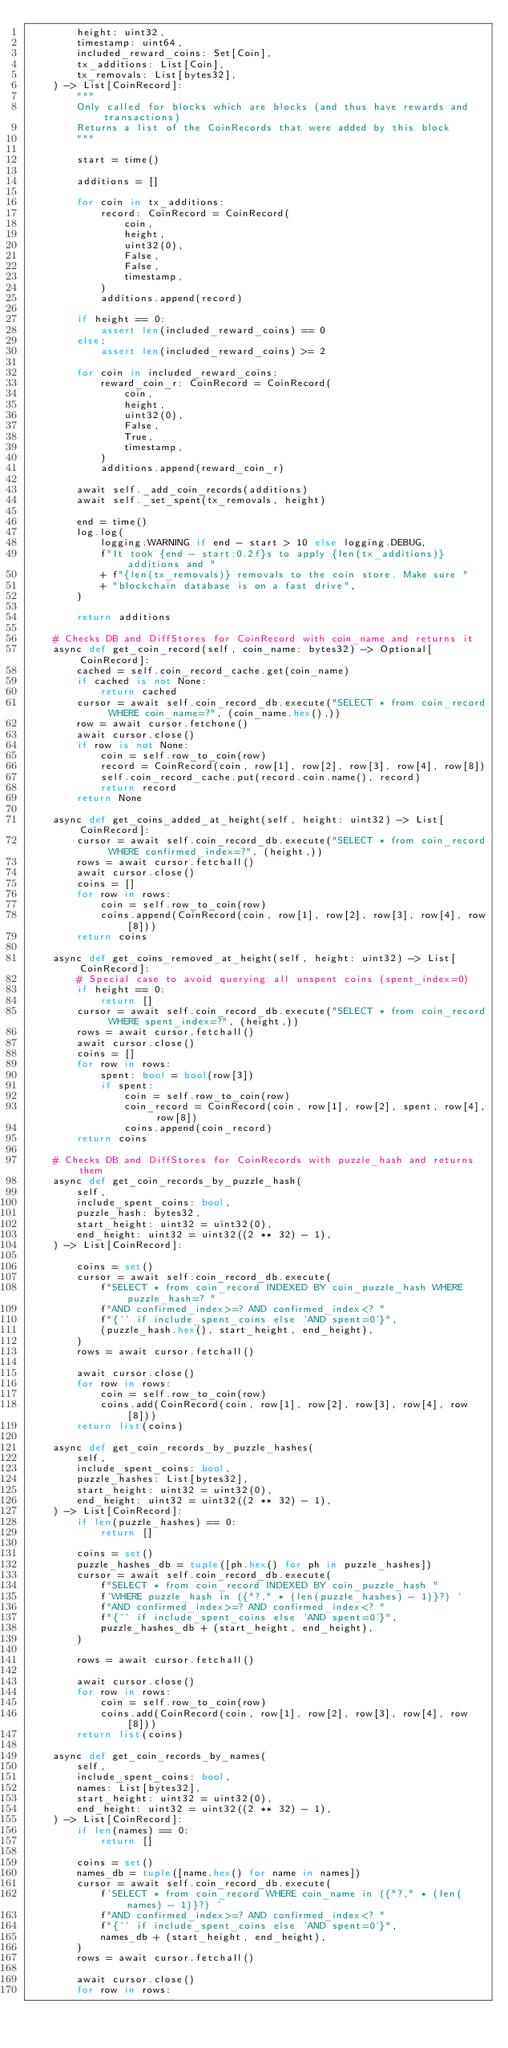<code> <loc_0><loc_0><loc_500><loc_500><_Python_>        height: uint32,
        timestamp: uint64,
        included_reward_coins: Set[Coin],
        tx_additions: List[Coin],
        tx_removals: List[bytes32],
    ) -> List[CoinRecord]:
        """
        Only called for blocks which are blocks (and thus have rewards and transactions)
        Returns a list of the CoinRecords that were added by this block
        """

        start = time()

        additions = []

        for coin in tx_additions:
            record: CoinRecord = CoinRecord(
                coin,
                height,
                uint32(0),
                False,
                False,
                timestamp,
            )
            additions.append(record)

        if height == 0:
            assert len(included_reward_coins) == 0
        else:
            assert len(included_reward_coins) >= 2

        for coin in included_reward_coins:
            reward_coin_r: CoinRecord = CoinRecord(
                coin,
                height,
                uint32(0),
                False,
                True,
                timestamp,
            )
            additions.append(reward_coin_r)

        await self._add_coin_records(additions)
        await self._set_spent(tx_removals, height)

        end = time()
        log.log(
            logging.WARNING if end - start > 10 else logging.DEBUG,
            f"It took {end - start:0.2f}s to apply {len(tx_additions)} additions and "
            + f"{len(tx_removals)} removals to the coin store. Make sure "
            + "blockchain database is on a fast drive",
        )

        return additions

    # Checks DB and DiffStores for CoinRecord with coin_name and returns it
    async def get_coin_record(self, coin_name: bytes32) -> Optional[CoinRecord]:
        cached = self.coin_record_cache.get(coin_name)
        if cached is not None:
            return cached
        cursor = await self.coin_record_db.execute("SELECT * from coin_record WHERE coin_name=?", (coin_name.hex(),))
        row = await cursor.fetchone()
        await cursor.close()
        if row is not None:
            coin = self.row_to_coin(row)
            record = CoinRecord(coin, row[1], row[2], row[3], row[4], row[8])
            self.coin_record_cache.put(record.coin.name(), record)
            return record
        return None

    async def get_coins_added_at_height(self, height: uint32) -> List[CoinRecord]:
        cursor = await self.coin_record_db.execute("SELECT * from coin_record WHERE confirmed_index=?", (height,))
        rows = await cursor.fetchall()
        await cursor.close()
        coins = []
        for row in rows:
            coin = self.row_to_coin(row)
            coins.append(CoinRecord(coin, row[1], row[2], row[3], row[4], row[8]))
        return coins

    async def get_coins_removed_at_height(self, height: uint32) -> List[CoinRecord]:
        # Special case to avoid querying all unspent coins (spent_index=0)
        if height == 0:
            return []
        cursor = await self.coin_record_db.execute("SELECT * from coin_record WHERE spent_index=?", (height,))
        rows = await cursor.fetchall()
        await cursor.close()
        coins = []
        for row in rows:
            spent: bool = bool(row[3])
            if spent:
                coin = self.row_to_coin(row)
                coin_record = CoinRecord(coin, row[1], row[2], spent, row[4], row[8])
                coins.append(coin_record)
        return coins

    # Checks DB and DiffStores for CoinRecords with puzzle_hash and returns them
    async def get_coin_records_by_puzzle_hash(
        self,
        include_spent_coins: bool,
        puzzle_hash: bytes32,
        start_height: uint32 = uint32(0),
        end_height: uint32 = uint32((2 ** 32) - 1),
    ) -> List[CoinRecord]:

        coins = set()
        cursor = await self.coin_record_db.execute(
            f"SELECT * from coin_record INDEXED BY coin_puzzle_hash WHERE puzzle_hash=? "
            f"AND confirmed_index>=? AND confirmed_index<? "
            f"{'' if include_spent_coins else 'AND spent=0'}",
            (puzzle_hash.hex(), start_height, end_height),
        )
        rows = await cursor.fetchall()

        await cursor.close()
        for row in rows:
            coin = self.row_to_coin(row)
            coins.add(CoinRecord(coin, row[1], row[2], row[3], row[4], row[8]))
        return list(coins)

    async def get_coin_records_by_puzzle_hashes(
        self,
        include_spent_coins: bool,
        puzzle_hashes: List[bytes32],
        start_height: uint32 = uint32(0),
        end_height: uint32 = uint32((2 ** 32) - 1),
    ) -> List[CoinRecord]:
        if len(puzzle_hashes) == 0:
            return []

        coins = set()
        puzzle_hashes_db = tuple([ph.hex() for ph in puzzle_hashes])
        cursor = await self.coin_record_db.execute(
            f"SELECT * from coin_record INDEXED BY coin_puzzle_hash "
            f'WHERE puzzle_hash in ({"?," * (len(puzzle_hashes) - 1)}?) '
            f"AND confirmed_index>=? AND confirmed_index<? "
            f"{'' if include_spent_coins else 'AND spent=0'}",
            puzzle_hashes_db + (start_height, end_height),
        )

        rows = await cursor.fetchall()

        await cursor.close()
        for row in rows:
            coin = self.row_to_coin(row)
            coins.add(CoinRecord(coin, row[1], row[2], row[3], row[4], row[8]))
        return list(coins)

    async def get_coin_records_by_names(
        self,
        include_spent_coins: bool,
        names: List[bytes32],
        start_height: uint32 = uint32(0),
        end_height: uint32 = uint32((2 ** 32) - 1),
    ) -> List[CoinRecord]:
        if len(names) == 0:
            return []

        coins = set()
        names_db = tuple([name.hex() for name in names])
        cursor = await self.coin_record_db.execute(
            f'SELECT * from coin_record WHERE coin_name in ({"?," * (len(names) - 1)}?) '
            f"AND confirmed_index>=? AND confirmed_index<? "
            f"{'' if include_spent_coins else 'AND spent=0'}",
            names_db + (start_height, end_height),
        )
        rows = await cursor.fetchall()

        await cursor.close()
        for row in rows:</code> 